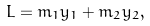Convert formula to latex. <formula><loc_0><loc_0><loc_500><loc_500>L = m _ { 1 } y _ { 1 } + m _ { 2 } y _ { 2 } ,</formula> 